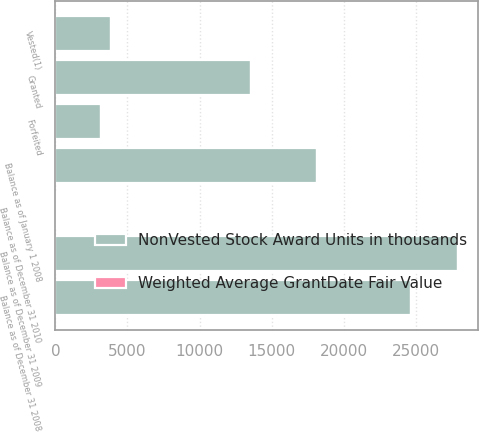<chart> <loc_0><loc_0><loc_500><loc_500><stacked_bar_chart><ecel><fcel>Balance as of January 1 2008<fcel>Granted<fcel>Vested(1)<fcel>Forfeited<fcel>Balance as of December 31 2008<fcel>Balance as of December 31 2009<fcel>Balance as of December 31 2010<nl><fcel>NonVested Stock Award Units in thousands<fcel>18136<fcel>13557<fcel>3856<fcel>3183<fcel>24654<fcel>27890<fcel>21<nl><fcel>Weighted Average GrantDate Fair Value<fcel>20<fcel>12<fcel>21<fcel>18<fcel>16<fcel>12<fcel>9<nl></chart> 